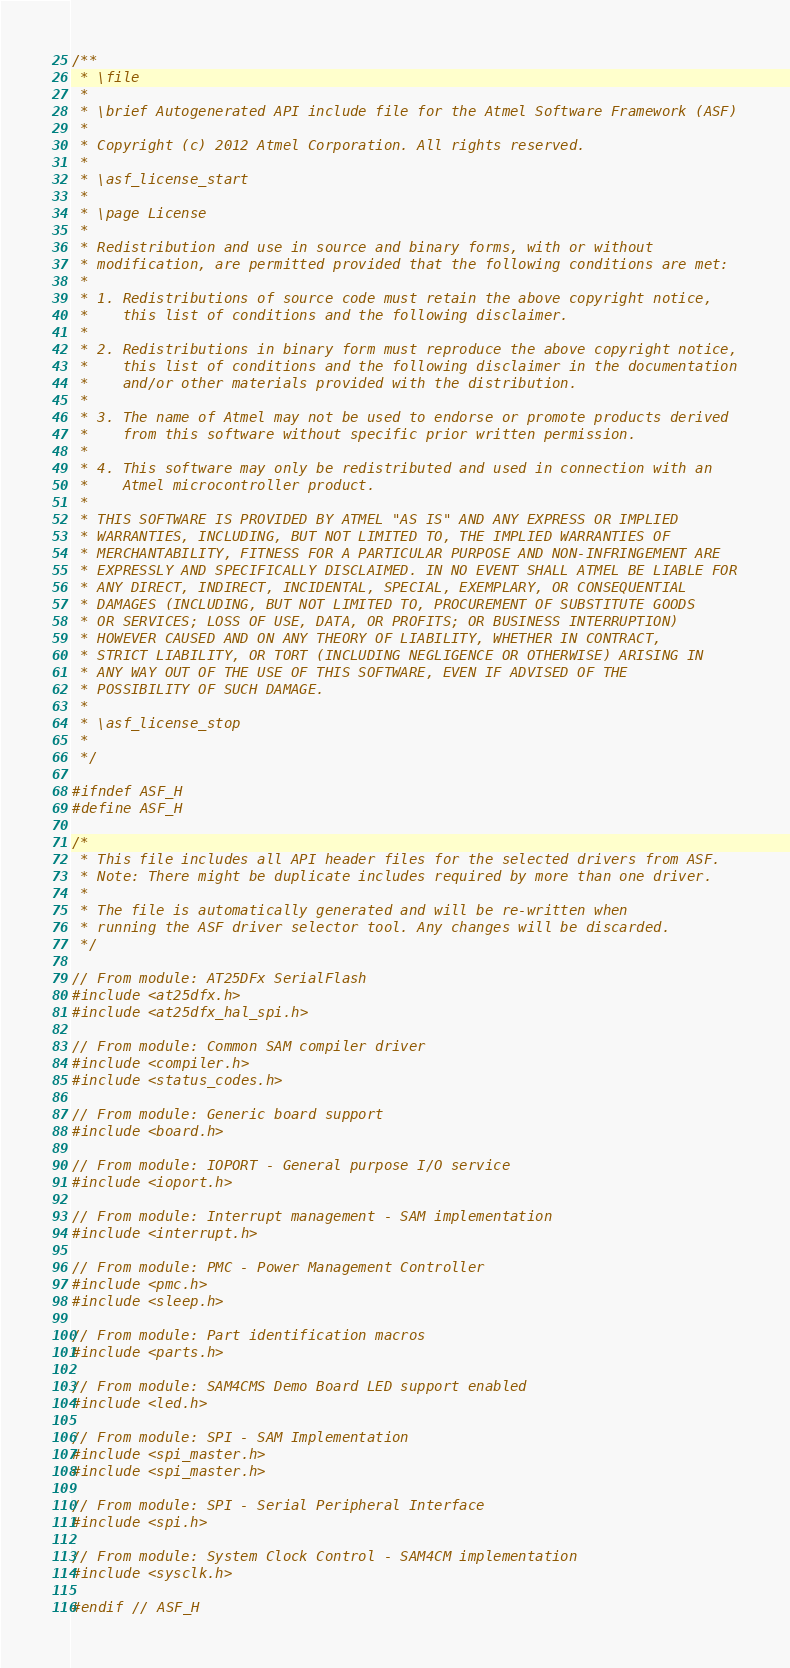Convert code to text. <code><loc_0><loc_0><loc_500><loc_500><_C_>/**
 * \file
 *
 * \brief Autogenerated API include file for the Atmel Software Framework (ASF)
 *
 * Copyright (c) 2012 Atmel Corporation. All rights reserved.
 *
 * \asf_license_start
 *
 * \page License
 *
 * Redistribution and use in source and binary forms, with or without
 * modification, are permitted provided that the following conditions are met:
 *
 * 1. Redistributions of source code must retain the above copyright notice,
 *    this list of conditions and the following disclaimer.
 *
 * 2. Redistributions in binary form must reproduce the above copyright notice,
 *    this list of conditions and the following disclaimer in the documentation
 *    and/or other materials provided with the distribution.
 *
 * 3. The name of Atmel may not be used to endorse or promote products derived
 *    from this software without specific prior written permission.
 *
 * 4. This software may only be redistributed and used in connection with an
 *    Atmel microcontroller product.
 *
 * THIS SOFTWARE IS PROVIDED BY ATMEL "AS IS" AND ANY EXPRESS OR IMPLIED
 * WARRANTIES, INCLUDING, BUT NOT LIMITED TO, THE IMPLIED WARRANTIES OF
 * MERCHANTABILITY, FITNESS FOR A PARTICULAR PURPOSE AND NON-INFRINGEMENT ARE
 * EXPRESSLY AND SPECIFICALLY DISCLAIMED. IN NO EVENT SHALL ATMEL BE LIABLE FOR
 * ANY DIRECT, INDIRECT, INCIDENTAL, SPECIAL, EXEMPLARY, OR CONSEQUENTIAL
 * DAMAGES (INCLUDING, BUT NOT LIMITED TO, PROCUREMENT OF SUBSTITUTE GOODS
 * OR SERVICES; LOSS OF USE, DATA, OR PROFITS; OR BUSINESS INTERRUPTION)
 * HOWEVER CAUSED AND ON ANY THEORY OF LIABILITY, WHETHER IN CONTRACT,
 * STRICT LIABILITY, OR TORT (INCLUDING NEGLIGENCE OR OTHERWISE) ARISING IN
 * ANY WAY OUT OF THE USE OF THIS SOFTWARE, EVEN IF ADVISED OF THE
 * POSSIBILITY OF SUCH DAMAGE.
 *
 * \asf_license_stop
 *
 */

#ifndef ASF_H
#define ASF_H

/*
 * This file includes all API header files for the selected drivers from ASF.
 * Note: There might be duplicate includes required by more than one driver.
 *
 * The file is automatically generated and will be re-written when
 * running the ASF driver selector tool. Any changes will be discarded.
 */

// From module: AT25DFx SerialFlash
#include <at25dfx.h>
#include <at25dfx_hal_spi.h>

// From module: Common SAM compiler driver
#include <compiler.h>
#include <status_codes.h>

// From module: Generic board support
#include <board.h>

// From module: IOPORT - General purpose I/O service
#include <ioport.h>

// From module: Interrupt management - SAM implementation
#include <interrupt.h>

// From module: PMC - Power Management Controller
#include <pmc.h>
#include <sleep.h>

// From module: Part identification macros
#include <parts.h>

// From module: SAM4CMS Demo Board LED support enabled
#include <led.h>

// From module: SPI - SAM Implementation
#include <spi_master.h>
#include <spi_master.h>

// From module: SPI - Serial Peripheral Interface
#include <spi.h>

// From module: System Clock Control - SAM4CM implementation
#include <sysclk.h>

#endif // ASF_H
</code> 